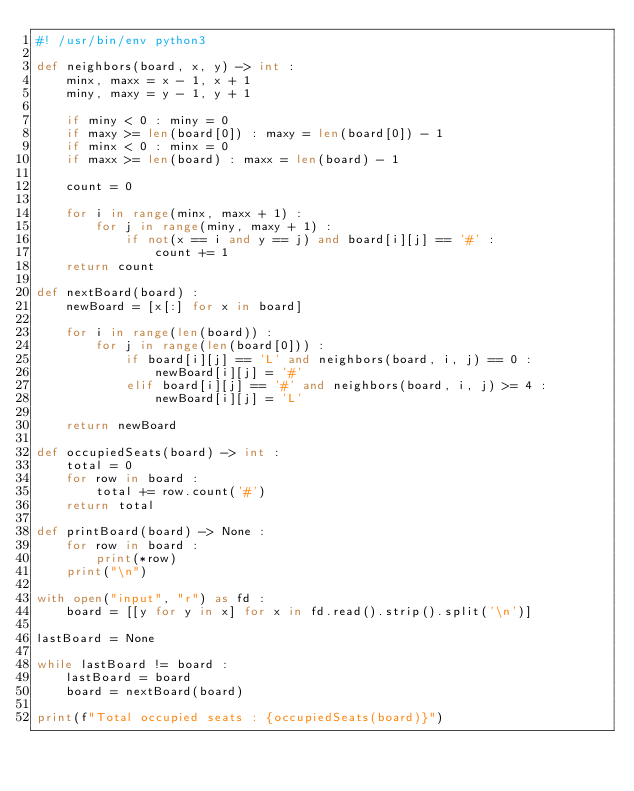Convert code to text. <code><loc_0><loc_0><loc_500><loc_500><_Python_>#! /usr/bin/env python3

def neighbors(board, x, y) -> int :
    minx, maxx = x - 1, x + 1
    miny, maxy = y - 1, y + 1

    if miny < 0 : miny = 0
    if maxy >= len(board[0]) : maxy = len(board[0]) - 1
    if minx < 0 : minx = 0
    if maxx >= len(board) : maxx = len(board) - 1

    count = 0

    for i in range(minx, maxx + 1) :
        for j in range(miny, maxy + 1) :
            if not(x == i and y == j) and board[i][j] == '#' :
                count += 1
    return count

def nextBoard(board) :
    newBoard = [x[:] for x in board]

    for i in range(len(board)) :
        for j in range(len(board[0])) :
            if board[i][j] == 'L' and neighbors(board, i, j) == 0 :
                newBoard[i][j] = '#'
            elif board[i][j] == '#' and neighbors(board, i, j) >= 4 :
                newBoard[i][j] = 'L'

    return newBoard

def occupiedSeats(board) -> int :
    total = 0
    for row in board :
        total += row.count('#')
    return total

def printBoard(board) -> None :
    for row in board :
        print(*row)
    print("\n")

with open("input", "r") as fd :
    board = [[y for y in x] for x in fd.read().strip().split('\n')]

lastBoard = None

while lastBoard != board :
    lastBoard = board
    board = nextBoard(board)

print(f"Total occupied seats : {occupiedSeats(board)}")</code> 